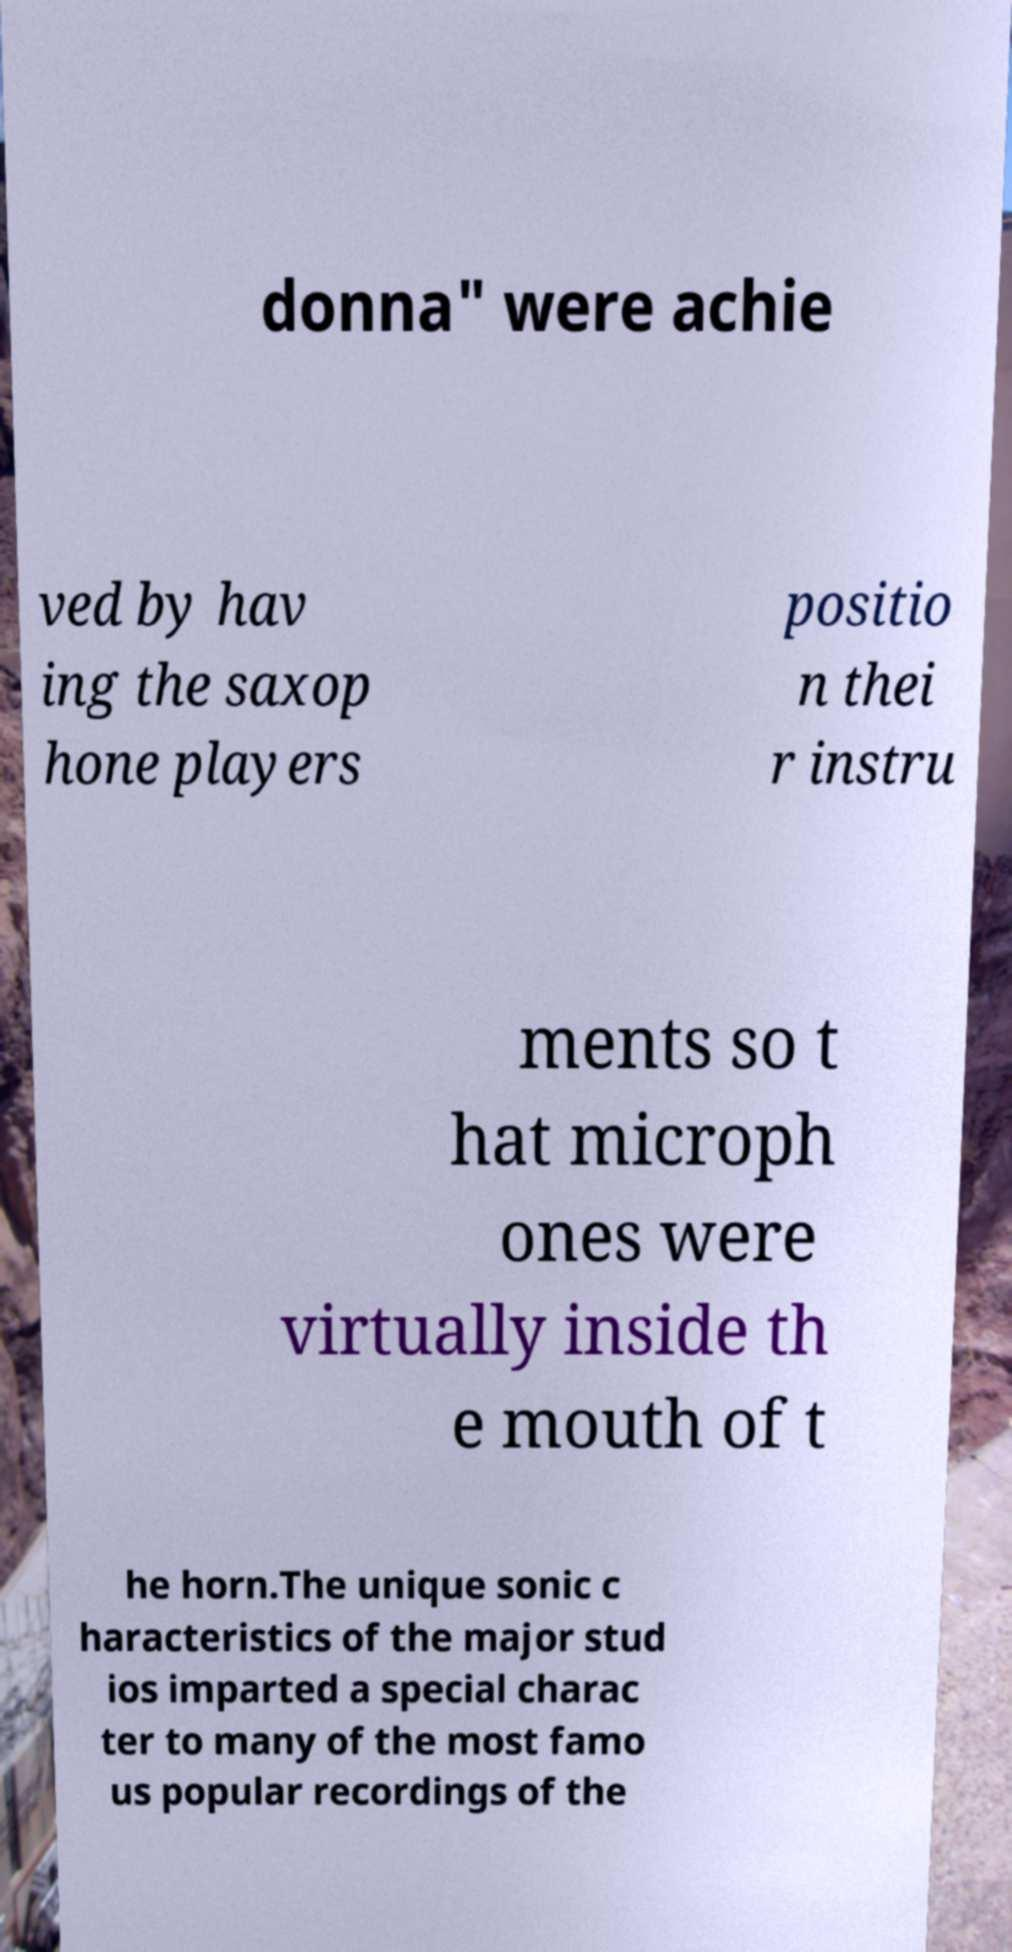Please read and relay the text visible in this image. What does it say? donna" were achie ved by hav ing the saxop hone players positio n thei r instru ments so t hat microph ones were virtually inside th e mouth of t he horn.The unique sonic c haracteristics of the major stud ios imparted a special charac ter to many of the most famo us popular recordings of the 